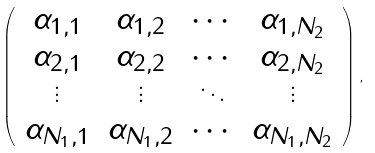Convert formula to latex. <formula><loc_0><loc_0><loc_500><loc_500>\left ( \begin{array} { c c c c } \alpha _ { 1 , 1 } & \alpha _ { 1 , 2 } & \cdots & \alpha _ { 1 , N _ { 2 } } \\ \alpha _ { 2 , 1 } & \alpha _ { 2 , 2 } & \cdots & \alpha _ { 2 , N _ { 2 } } \\ \vdots & \vdots & \ddots & \vdots \\ \alpha _ { N _ { 1 } , 1 } & \alpha _ { N _ { 1 } , 2 } & \cdots & \alpha _ { N _ { 1 } , N _ { 2 } } \\ \end{array} \right ) ,</formula> 